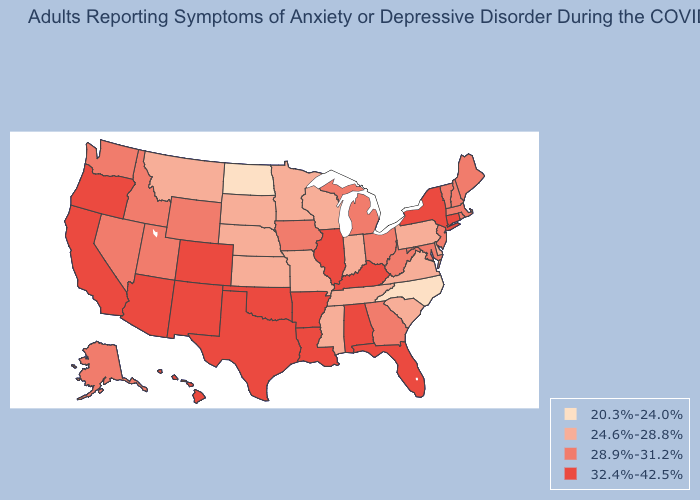Among the states that border Kansas , which have the lowest value?
Give a very brief answer. Missouri, Nebraska. Which states have the lowest value in the USA?
Keep it brief. North Carolina, North Dakota. Among the states that border Wyoming , which have the lowest value?
Keep it brief. Montana, Nebraska, South Dakota. Name the states that have a value in the range 28.9%-31.2%?
Concise answer only. Alaska, Georgia, Idaho, Iowa, Maine, Maryland, Massachusetts, Michigan, Nevada, New Hampshire, New Jersey, Ohio, Rhode Island, Utah, Vermont, Washington, West Virginia, Wyoming. What is the lowest value in the USA?
Keep it brief. 20.3%-24.0%. Does North Dakota have the lowest value in the MidWest?
Be succinct. Yes. How many symbols are there in the legend?
Short answer required. 4. Name the states that have a value in the range 24.6%-28.8%?
Be succinct. Delaware, Indiana, Kansas, Minnesota, Mississippi, Missouri, Montana, Nebraska, Pennsylvania, South Carolina, South Dakota, Tennessee, Virginia, Wisconsin. What is the value of Louisiana?
Quick response, please. 32.4%-42.5%. Which states have the highest value in the USA?
Quick response, please. Alabama, Arizona, Arkansas, California, Colorado, Connecticut, Florida, Hawaii, Illinois, Kentucky, Louisiana, New Mexico, New York, Oklahoma, Oregon, Texas. Among the states that border South Dakota , which have the highest value?
Be succinct. Iowa, Wyoming. What is the value of Indiana?
Write a very short answer. 24.6%-28.8%. Is the legend a continuous bar?
Be succinct. No. What is the value of New Jersey?
Write a very short answer. 28.9%-31.2%. What is the value of Kansas?
Answer briefly. 24.6%-28.8%. 